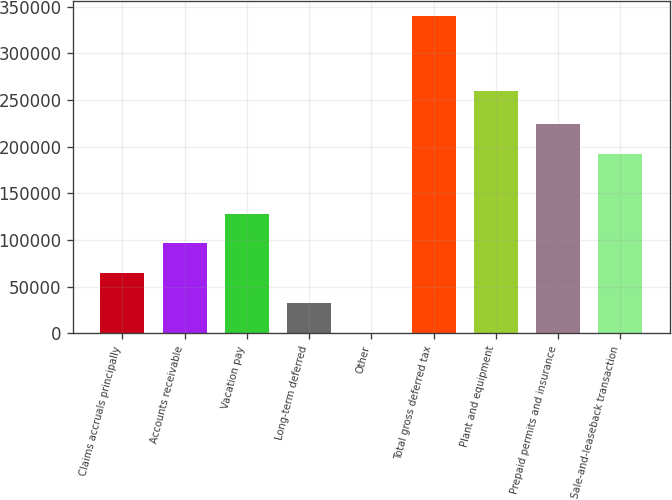Convert chart to OTSL. <chart><loc_0><loc_0><loc_500><loc_500><bar_chart><fcel>Claims accruals principally<fcel>Accounts receivable<fcel>Vacation pay<fcel>Long-term deferred<fcel>Other<fcel>Total gross deferred tax<fcel>Plant and equipment<fcel>Prepaid permits and insurance<fcel>Sale-and-leaseback transaction<nl><fcel>64465.2<fcel>96358.8<fcel>128252<fcel>32571.6<fcel>678<fcel>339549<fcel>259999<fcel>223933<fcel>192040<nl></chart> 